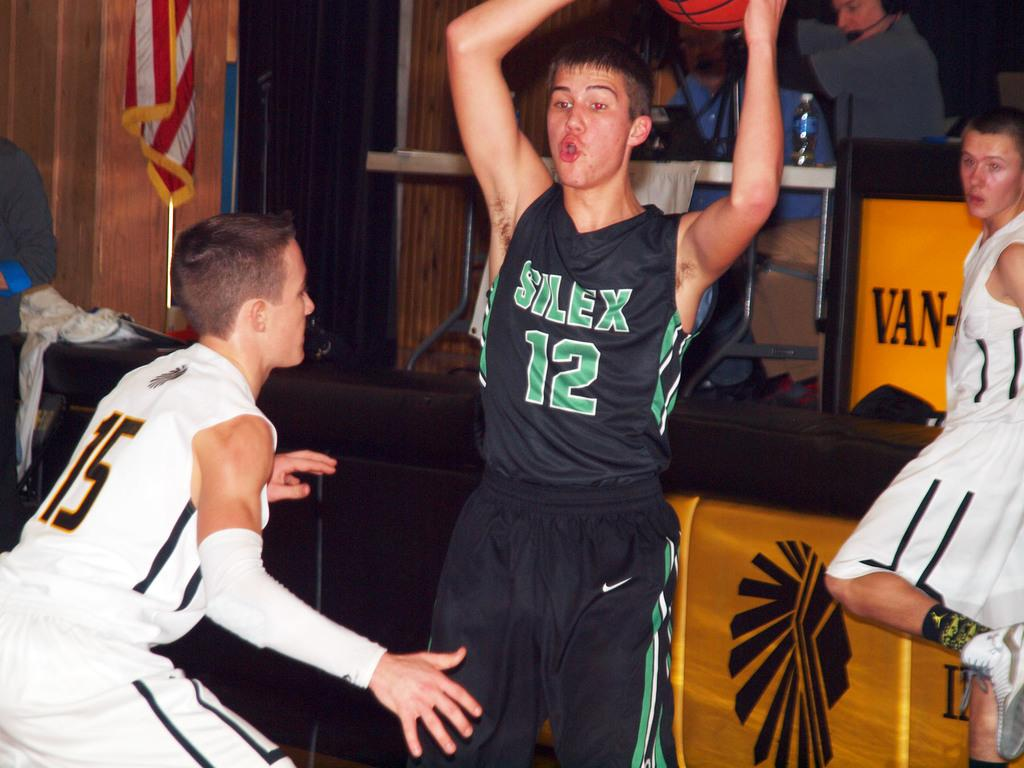Provide a one-sentence caption for the provided image. Player number 12 holds the basketball over his head to keep it away from number 15. 